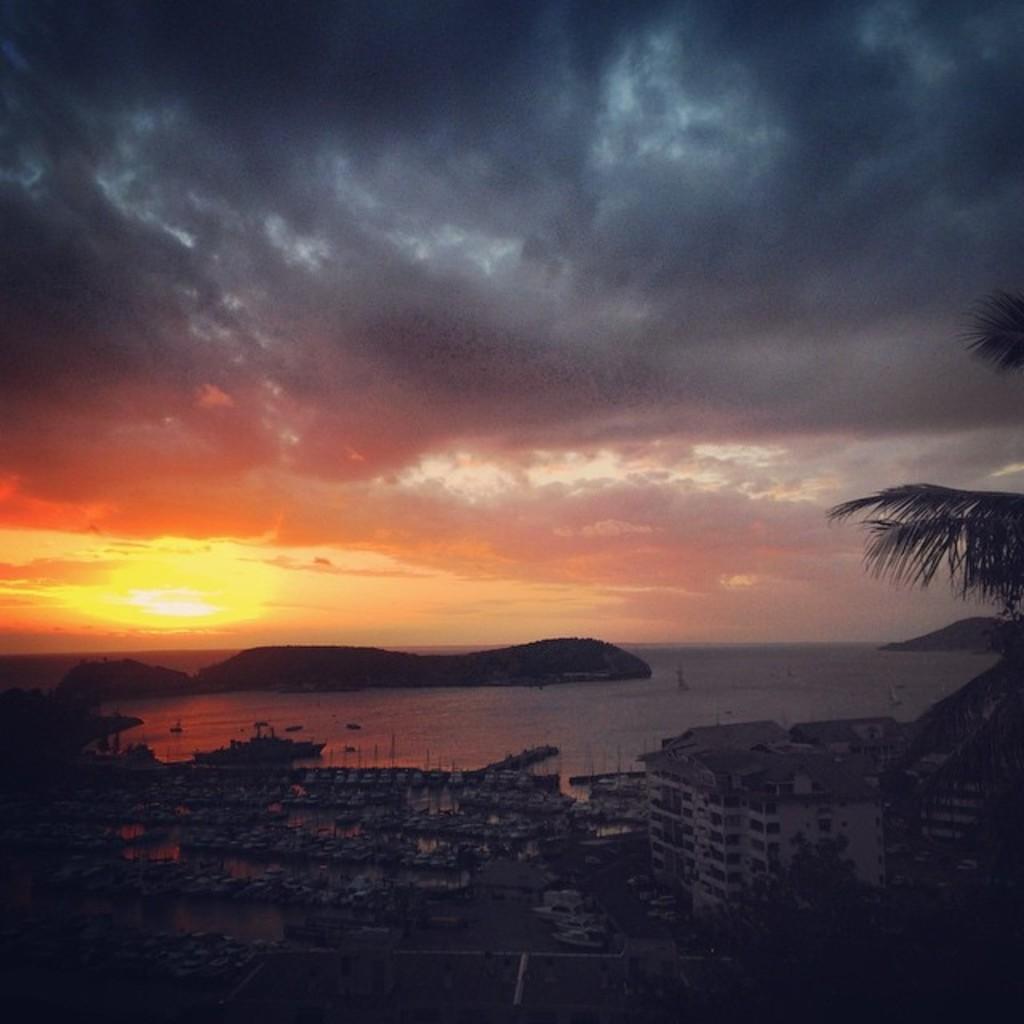Could you give a brief overview of what you see in this image? In this image I can see a building, water and in it I can see a boat. I can also see the sun, clouds, the sky, a tree and I can see this image is little bit in dark. 